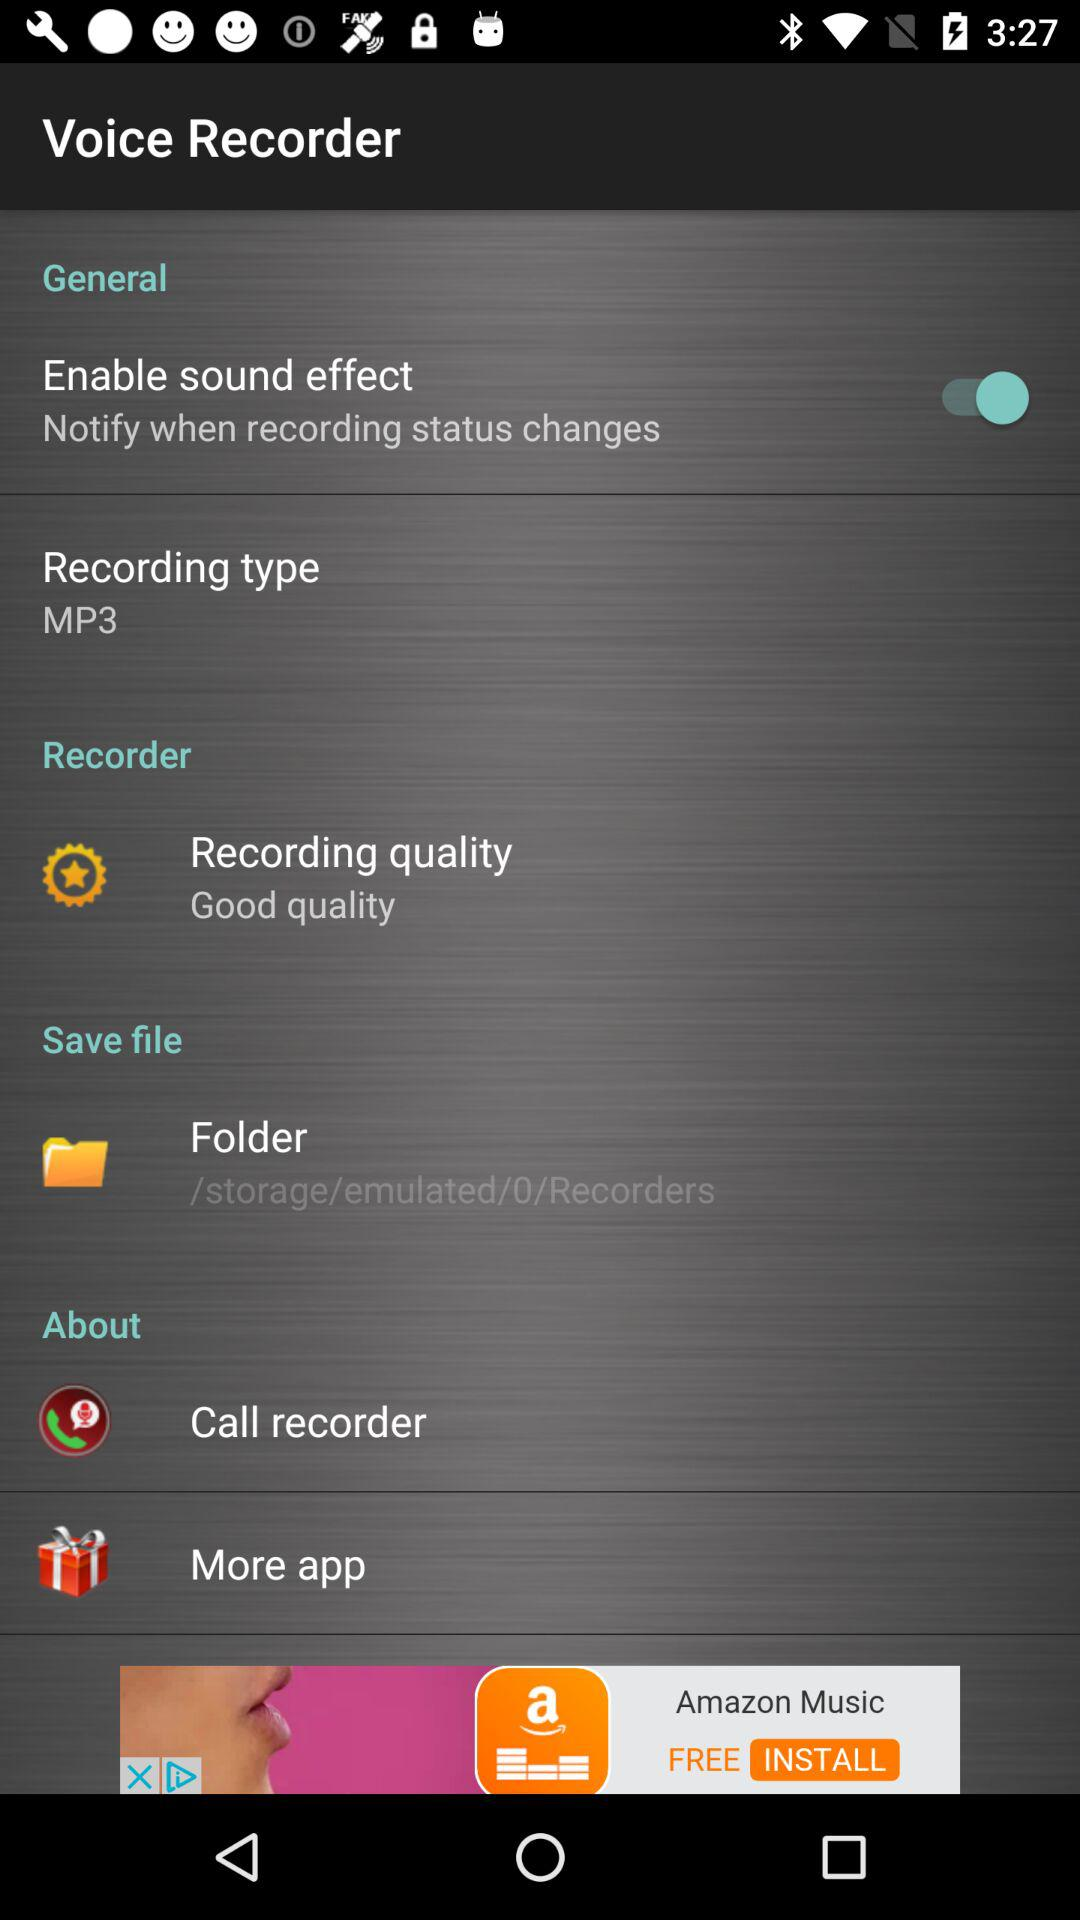What is the recording type? The recording type is MP3. 